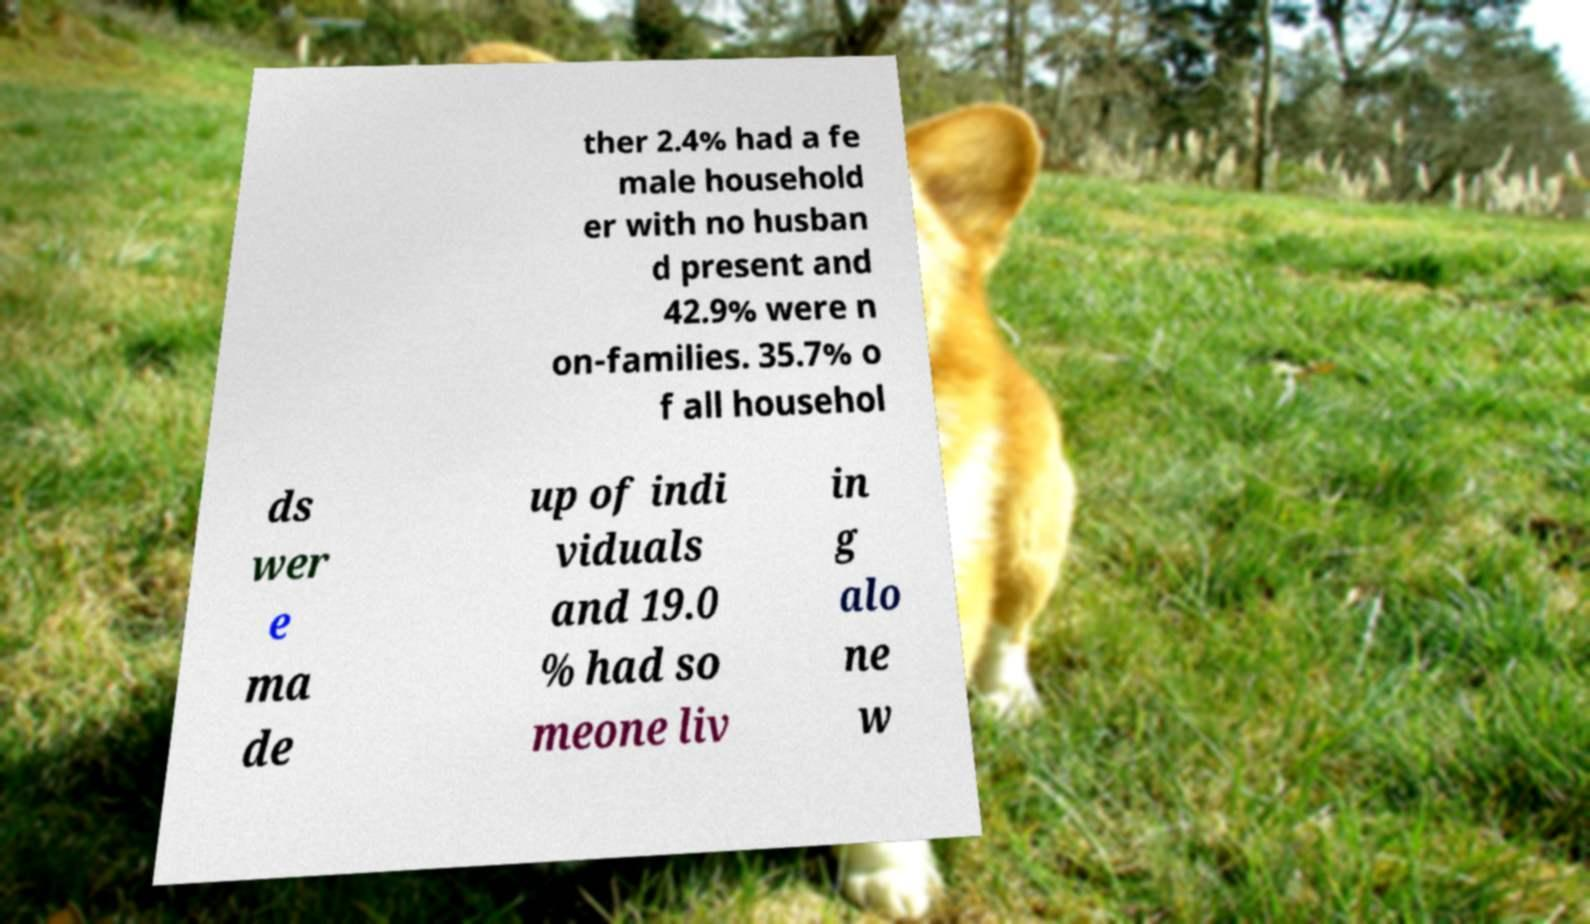There's text embedded in this image that I need extracted. Can you transcribe it verbatim? ther 2.4% had a fe male household er with no husban d present and 42.9% were n on-families. 35.7% o f all househol ds wer e ma de up of indi viduals and 19.0 % had so meone liv in g alo ne w 